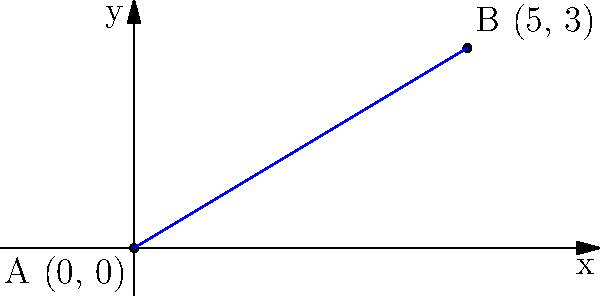You're planning a route between two cities for your next long-haul trip. On a coordinate plane, City A is located at (0, 0) and City B is at (5, 3), where each unit represents 100 miles. What is the slope of the road connecting these two cities? Round your answer to two decimal places. To find the slope of the road between the two cities, we can use the slope formula:

$$ \text{Slope} = \frac{y_2 - y_1}{x_2 - x_1} $$

Where $(x_1, y_1)$ represents the coordinates of City A and $(x_2, y_2)$ represents the coordinates of City B.

Step 1: Identify the coordinates
City A: $(x_1, y_1) = (0, 0)$
City B: $(x_2, y_2) = (5, 3)$

Step 2: Plug the values into the slope formula
$$ \text{Slope} = \frac{3 - 0}{5 - 0} = \frac{3}{5} $$

Step 3: Calculate the result
$$ \frac{3}{5} = 0.6 $$

Step 4: Round to two decimal places
The slope is already expressed with one decimal place, so it remains 0.60.

This slope indicates that for every 100 miles you travel horizontally (along the x-axis), you gain 60 miles in elevation (along the y-axis).
Answer: 0.60 